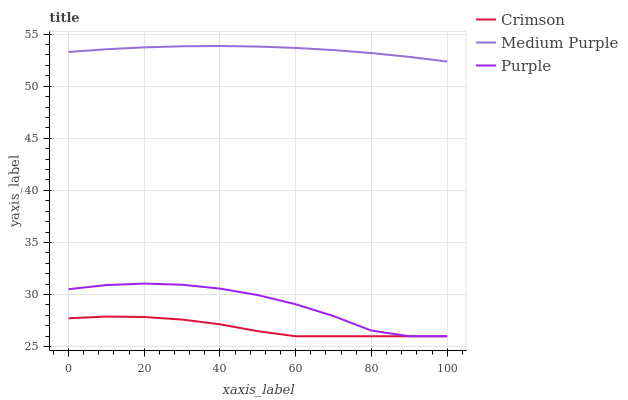Does Purple have the minimum area under the curve?
Answer yes or no. No. Does Purple have the maximum area under the curve?
Answer yes or no. No. Is Purple the smoothest?
Answer yes or no. No. Is Medium Purple the roughest?
Answer yes or no. No. Does Medium Purple have the lowest value?
Answer yes or no. No. Does Purple have the highest value?
Answer yes or no. No. Is Crimson less than Medium Purple?
Answer yes or no. Yes. Is Medium Purple greater than Crimson?
Answer yes or no. Yes. Does Crimson intersect Medium Purple?
Answer yes or no. No. 